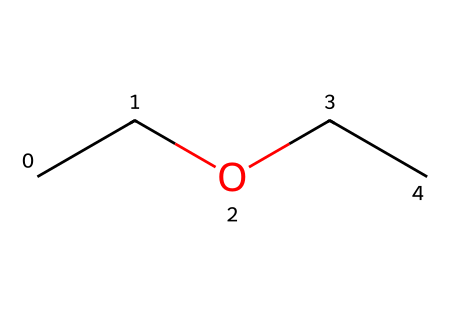What is the name of this chemical? The SMILES representation CC(O)CC corresponds to ethyl ether, which is commonly known as diethyl ether. The structure indicates two ethyl groups linked by an oxygen atom, which defines it as an ether.
Answer: diethyl ether How many carbon atoms are present in this structure? The SMILES indicates that there are two ethyl groups (each containing 2 carbon atoms), totaling 4 carbon atoms. Counting the carbon symbols in CC and CC from the structure, we can confirm this.
Answer: 4 What is the total number of oxygen atoms in this chemical? The structure contains a single 'O' which represents one oxygen atom. Hence, the total count is straightforward and can be directly observed in the SMILES.
Answer: 1 What type of bond connects the carbon atoms in the structure? The bonds connecting the carbon atoms in CC and CC are single covalent bonds, as indicated by the absence of any double bond notations in the SMILES.
Answer: single What functional group does ethyl ether belong to? The presence of the oxygen atom between two carbon chains indicates that this compound is an ether. Ethers are defined by the R-O-R' structure, where R and R' are carbon groups.
Answer: ether How many hydrogen atoms are in ethyl ether? Each ethyl group (C2H5) contributes five hydrogen atoms, so two ethyl groups contribute a total of ten hydrogen atoms. As the structure is complete, we don’t subtract any for functional groups.
Answer: 10 Does this chemical have any geometric isomers? Since there are only two ethyl groups attached by an oxygen atom and no double bonds or other substituents that would allow for different spatial arrangements, there are no geometric isomers for this molecule.
Answer: no 